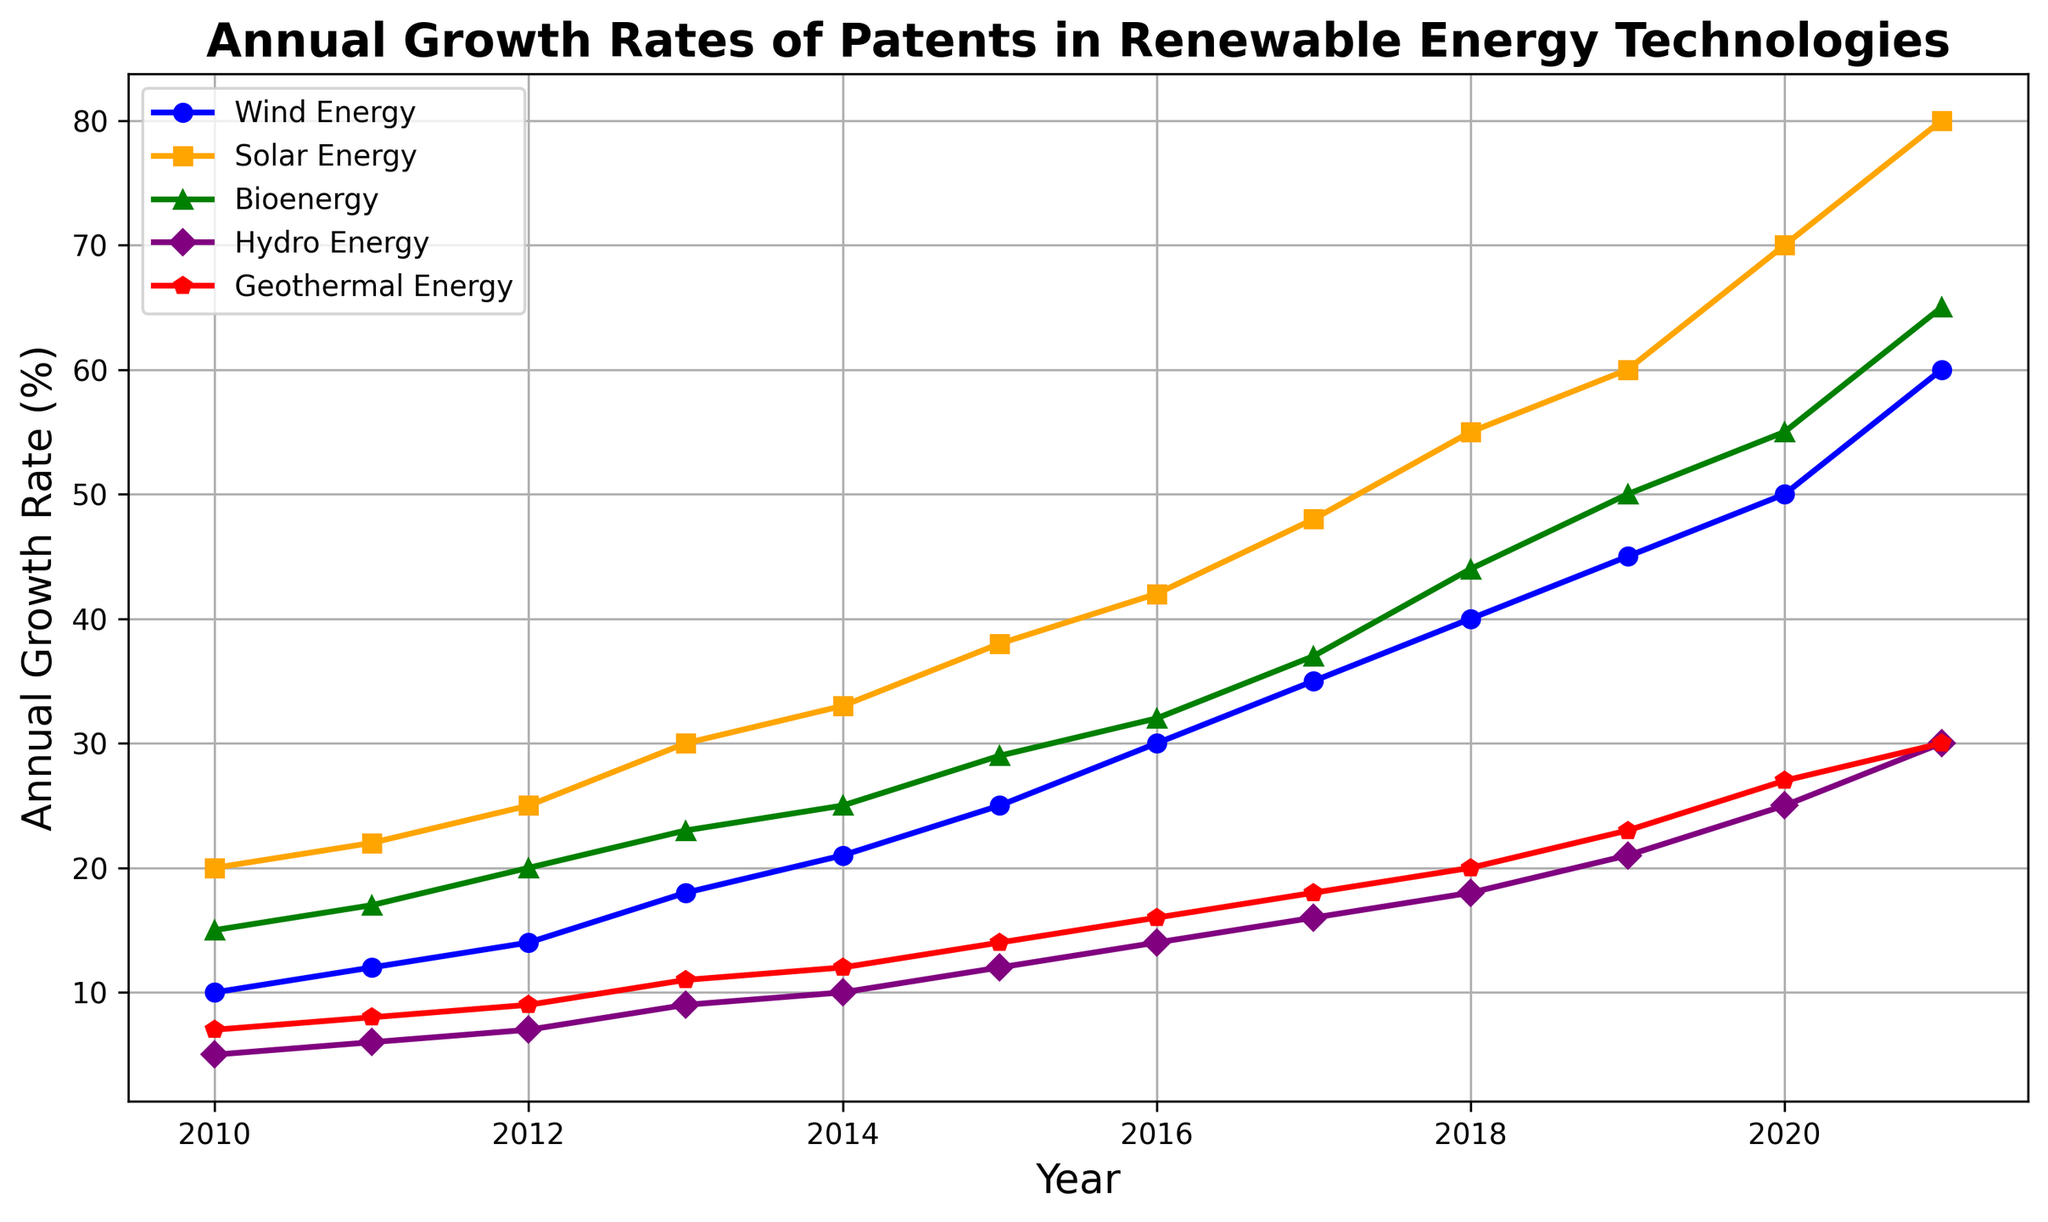What's the annual growth rate of Solar Energy patents in 2020? Look for the y-axis value corresponding to Solar Energy in 2020, which is 70.
Answer: 70 Which renewable energy technology had the highest growth rate in 2021? Compare the growth rates of all renewable energy technologies in 2021; Solar Energy has the highest at 80.
Answer: Solar Energy What's the difference in growth rates between Wind Energy and Bioenergy in 2016? Find the growth rates of Wind Energy and Bioenergy in 2016, which are 30 and 32 respectively. Then, subtract 30 from 32.
Answer: 2 Which two renewable energy categories had equal growth rates in 2021? Compare the growth rates of all categories in 2021. Bioenergy and Geothermal Energy both have a growth rate of 30.
Answer: Bioenergy and Geothermal Energy What's the average annual growth rate of Hydro Energy from 2010 to 2015? Take the growth rates for Hydro Energy from 2010 (5), 2011 (6), 2012 (7), 2013 (9), 2014 (10), and 2015 (12). Sum them up (5+6+7+9+10+12=49) and divide by the number of years, which is 6.
Answer: 8.17 In which year did Wind Energy first surpass a growth rate of 40? Look for the first year where Wind Energy's growth rate is greater than 40, which is 2018 (growth rate 40).
Answer: 2018 What is the difference in growth rates between the highest and lowest categories in 2013? The highest growth rate in 2013 is Solar Energy (30), and the lowest is Hydro Energy (9). Subtract 9 from 30.
Answer: 21 What trend do you observe for Geothermal Energy from 2010 to 2021? Geothermal Energy shows a consistent annual growth, increasing every year from 7 in 2010 to 30 in 2021.
Answer: Consistent increase How much higher was the growth rate of Solar Energy compared to Wind Energy in 2019? Solar Energy had a growth rate of 60 and Wind Energy had 45 in 2019. Subtract 45 from 60.
Answer: 15 Which categories showed an increase in growth rate every year without any decline from 2010 to 2021? Observe that all categories (Wind Energy, Solar Energy, Bioenergy, Hydro Energy, Geothermal Energy) show a consistent annual increase.
Answer: All categories 